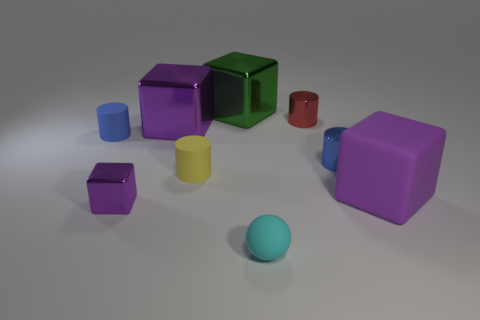What materials are the objects in the image made of and how can you tell? The objects in the image have a variety of colors and textures that suggest they could be made of different types of materials such as rubber and metal. We can infer this from their surfaces; rubber objects have a matte finish, while metal ones are likely to reflect light and have a shinier appearance. 